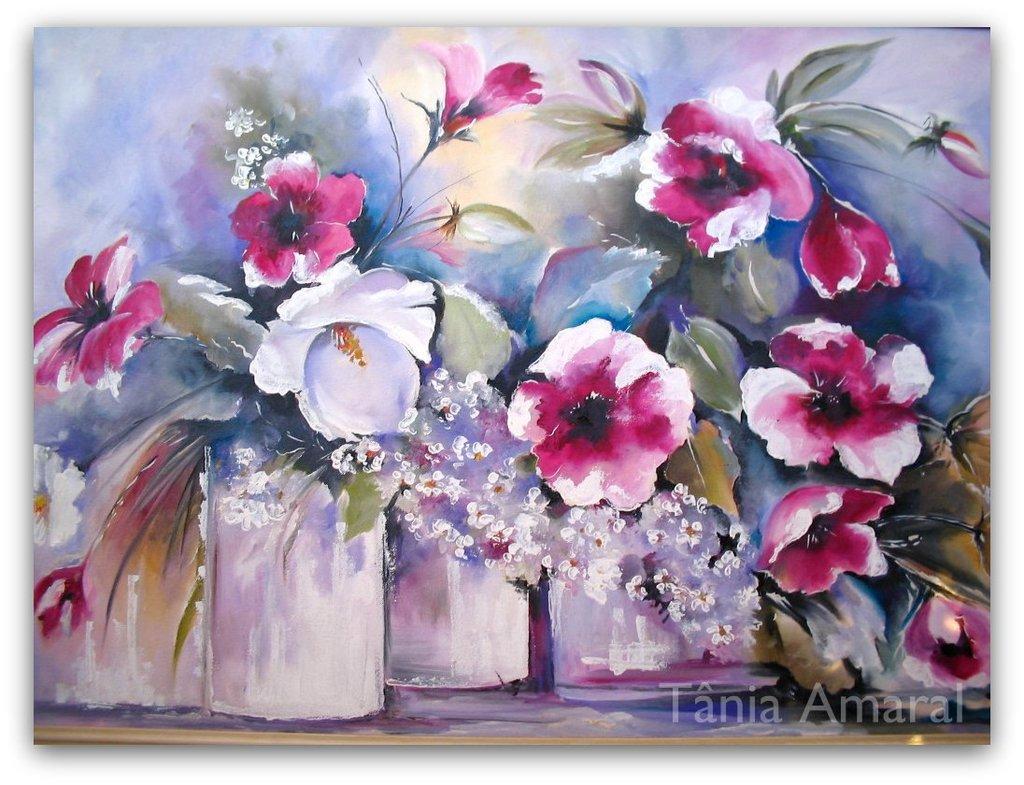Please provide a concise description of this image. In this picture we see a painting of flower pots with pink and white flowers and green leaves. 